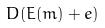<formula> <loc_0><loc_0><loc_500><loc_500>D ( E ( m ) + e )</formula> 